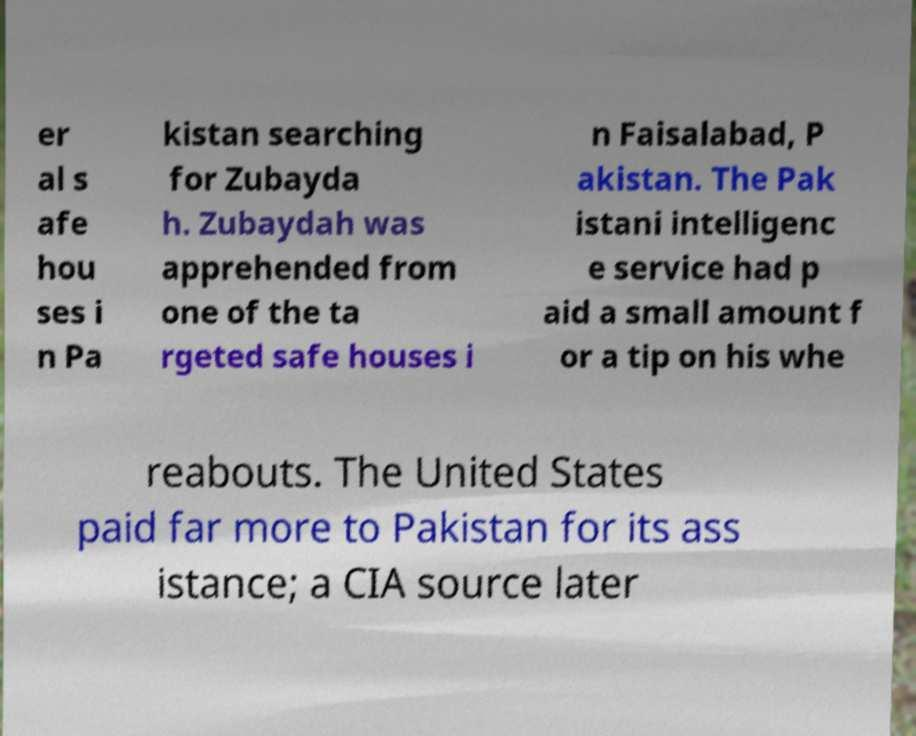Could you assist in decoding the text presented in this image and type it out clearly? er al s afe hou ses i n Pa kistan searching for Zubayda h. Zubaydah was apprehended from one of the ta rgeted safe houses i n Faisalabad, P akistan. The Pak istani intelligenc e service had p aid a small amount f or a tip on his whe reabouts. The United States paid far more to Pakistan for its ass istance; a CIA source later 